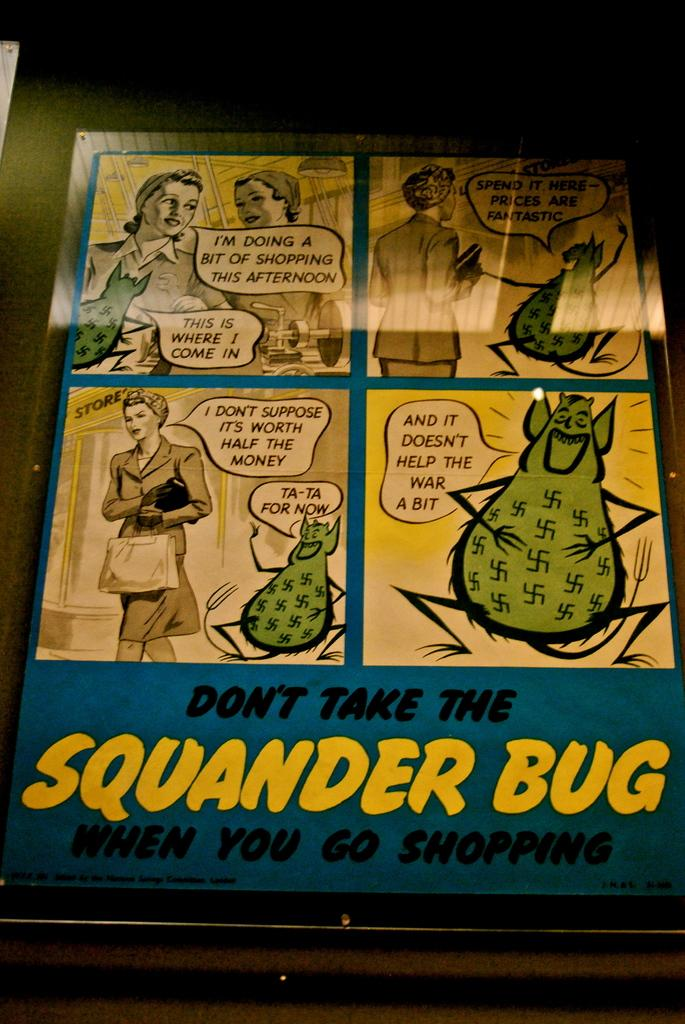<image>
Present a compact description of the photo's key features. a poster for Don't take the Squander Bug when you go shopping 